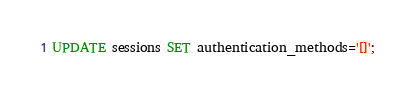<code> <loc_0><loc_0><loc_500><loc_500><_SQL_>UPDATE sessions SET authentication_methods='[]';</code> 